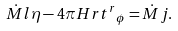<formula> <loc_0><loc_0><loc_500><loc_500>\dot { M } l \eta - 4 \pi H r { t ^ { r } } _ { \phi } = \dot { M } j .</formula> 